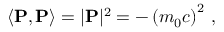<formula> <loc_0><loc_0><loc_500><loc_500>\left \langle P , P \right \rangle = | P | ^ { 2 } = - \left ( m _ { 0 } c \right ) ^ { 2 } \, ,</formula> 